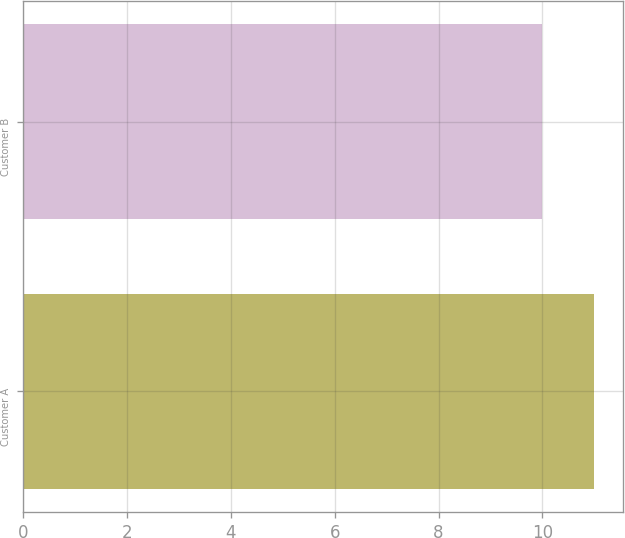Convert chart to OTSL. <chart><loc_0><loc_0><loc_500><loc_500><bar_chart><fcel>Customer A<fcel>Customer B<nl><fcel>11<fcel>10<nl></chart> 